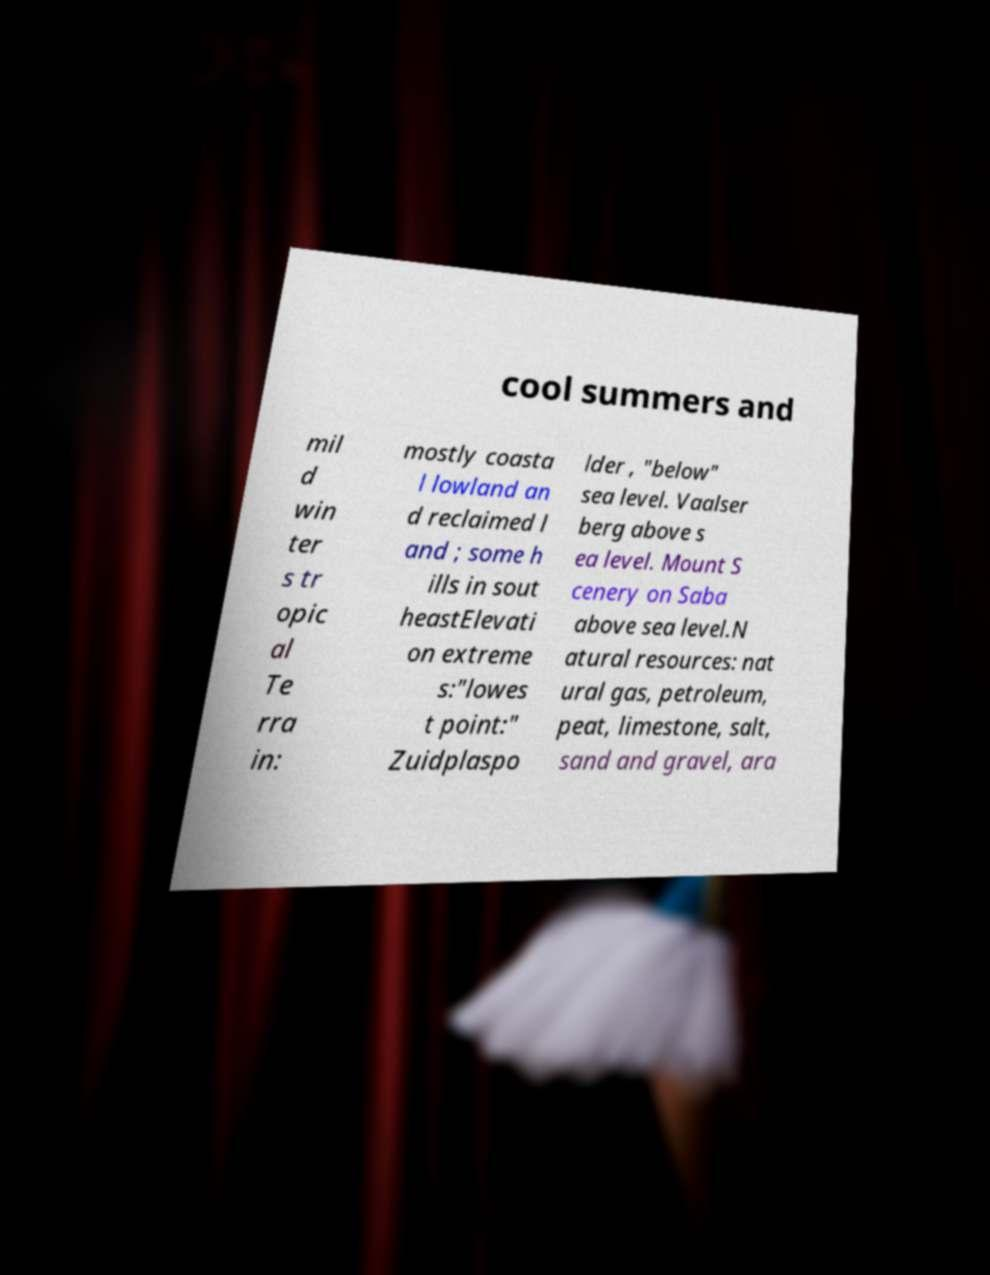For documentation purposes, I need the text within this image transcribed. Could you provide that? cool summers and mil d win ter s tr opic al Te rra in: mostly coasta l lowland an d reclaimed l and ; some h ills in sout heastElevati on extreme s:"lowes t point:" Zuidplaspo lder , "below" sea level. Vaalser berg above s ea level. Mount S cenery on Saba above sea level.N atural resources: nat ural gas, petroleum, peat, limestone, salt, sand and gravel, ara 